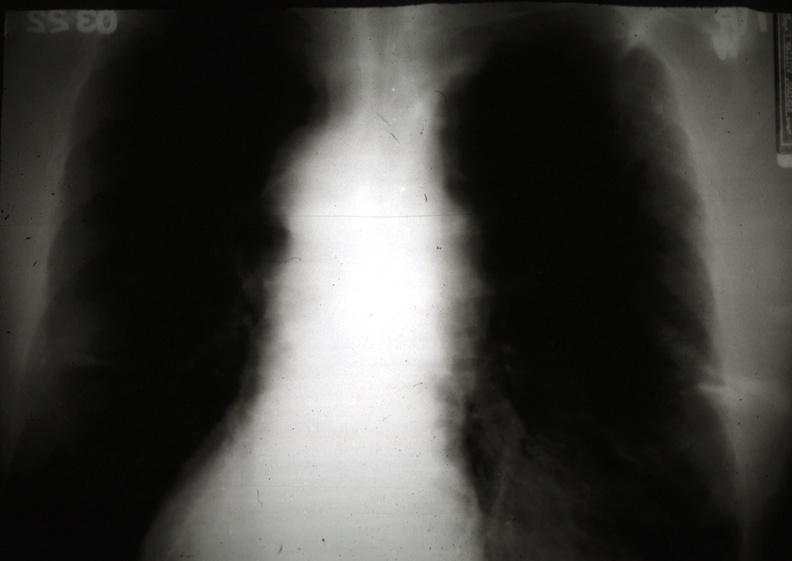s malignant thymoma present?
Answer the question using a single word or phrase. Yes 